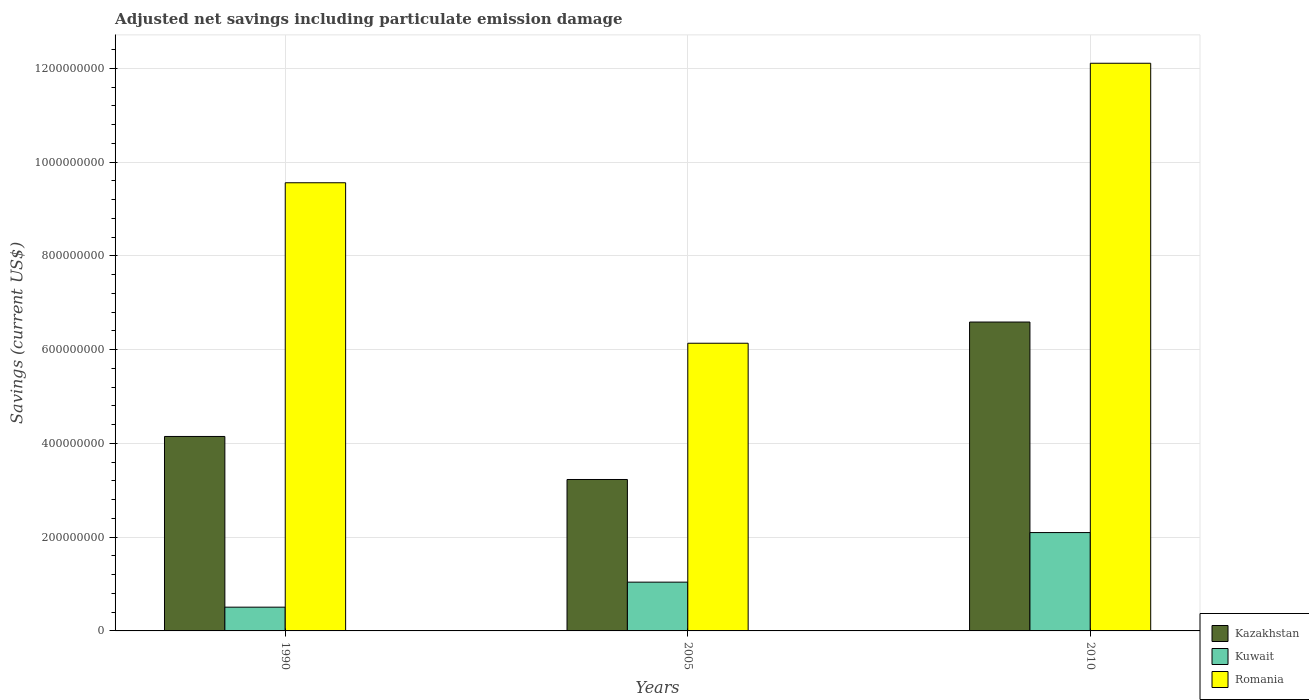How many different coloured bars are there?
Keep it short and to the point. 3. Are the number of bars per tick equal to the number of legend labels?
Your answer should be compact. Yes. How many bars are there on the 2nd tick from the left?
Offer a very short reply. 3. In how many cases, is the number of bars for a given year not equal to the number of legend labels?
Ensure brevity in your answer.  0. What is the net savings in Kazakhstan in 2005?
Give a very brief answer. 3.23e+08. Across all years, what is the maximum net savings in Romania?
Offer a terse response. 1.21e+09. Across all years, what is the minimum net savings in Kazakhstan?
Offer a very short reply. 3.23e+08. In which year was the net savings in Romania maximum?
Make the answer very short. 2010. In which year was the net savings in Romania minimum?
Provide a short and direct response. 2005. What is the total net savings in Kuwait in the graph?
Your answer should be very brief. 3.65e+08. What is the difference between the net savings in Kuwait in 1990 and that in 2010?
Offer a very short reply. -1.59e+08. What is the difference between the net savings in Kuwait in 2005 and the net savings in Romania in 1990?
Ensure brevity in your answer.  -8.52e+08. What is the average net savings in Kuwait per year?
Ensure brevity in your answer.  1.22e+08. In the year 1990, what is the difference between the net savings in Kazakhstan and net savings in Kuwait?
Offer a terse response. 3.64e+08. In how many years, is the net savings in Romania greater than 120000000 US$?
Your response must be concise. 3. What is the ratio of the net savings in Romania in 1990 to that in 2005?
Provide a succinct answer. 1.56. Is the net savings in Romania in 1990 less than that in 2010?
Your answer should be very brief. Yes. What is the difference between the highest and the second highest net savings in Kazakhstan?
Offer a terse response. 2.44e+08. What is the difference between the highest and the lowest net savings in Romania?
Provide a short and direct response. 5.97e+08. In how many years, is the net savings in Romania greater than the average net savings in Romania taken over all years?
Your answer should be very brief. 2. Is the sum of the net savings in Kazakhstan in 2005 and 2010 greater than the maximum net savings in Kuwait across all years?
Give a very brief answer. Yes. What does the 1st bar from the left in 2010 represents?
Provide a succinct answer. Kazakhstan. What does the 2nd bar from the right in 1990 represents?
Provide a short and direct response. Kuwait. Is it the case that in every year, the sum of the net savings in Romania and net savings in Kazakhstan is greater than the net savings in Kuwait?
Offer a very short reply. Yes. How many bars are there?
Give a very brief answer. 9. Does the graph contain any zero values?
Your answer should be compact. No. Does the graph contain grids?
Your answer should be very brief. Yes. Where does the legend appear in the graph?
Provide a succinct answer. Bottom right. How are the legend labels stacked?
Your answer should be very brief. Vertical. What is the title of the graph?
Provide a short and direct response. Adjusted net savings including particulate emission damage. Does "Dominica" appear as one of the legend labels in the graph?
Provide a short and direct response. No. What is the label or title of the X-axis?
Provide a short and direct response. Years. What is the label or title of the Y-axis?
Provide a succinct answer. Savings (current US$). What is the Savings (current US$) of Kazakhstan in 1990?
Make the answer very short. 4.15e+08. What is the Savings (current US$) of Kuwait in 1990?
Your answer should be very brief. 5.07e+07. What is the Savings (current US$) of Romania in 1990?
Offer a very short reply. 9.56e+08. What is the Savings (current US$) of Kazakhstan in 2005?
Ensure brevity in your answer.  3.23e+08. What is the Savings (current US$) in Kuwait in 2005?
Offer a very short reply. 1.04e+08. What is the Savings (current US$) in Romania in 2005?
Ensure brevity in your answer.  6.14e+08. What is the Savings (current US$) in Kazakhstan in 2010?
Your answer should be compact. 6.59e+08. What is the Savings (current US$) in Kuwait in 2010?
Offer a terse response. 2.10e+08. What is the Savings (current US$) in Romania in 2010?
Provide a succinct answer. 1.21e+09. Across all years, what is the maximum Savings (current US$) of Kazakhstan?
Your answer should be very brief. 6.59e+08. Across all years, what is the maximum Savings (current US$) of Kuwait?
Provide a succinct answer. 2.10e+08. Across all years, what is the maximum Savings (current US$) of Romania?
Keep it short and to the point. 1.21e+09. Across all years, what is the minimum Savings (current US$) in Kazakhstan?
Give a very brief answer. 3.23e+08. Across all years, what is the minimum Savings (current US$) of Kuwait?
Give a very brief answer. 5.07e+07. Across all years, what is the minimum Savings (current US$) of Romania?
Keep it short and to the point. 6.14e+08. What is the total Savings (current US$) of Kazakhstan in the graph?
Provide a succinct answer. 1.40e+09. What is the total Savings (current US$) in Kuwait in the graph?
Ensure brevity in your answer.  3.65e+08. What is the total Savings (current US$) in Romania in the graph?
Make the answer very short. 2.78e+09. What is the difference between the Savings (current US$) in Kazakhstan in 1990 and that in 2005?
Provide a succinct answer. 9.18e+07. What is the difference between the Savings (current US$) in Kuwait in 1990 and that in 2005?
Your answer should be very brief. -5.34e+07. What is the difference between the Savings (current US$) of Romania in 1990 and that in 2005?
Ensure brevity in your answer.  3.42e+08. What is the difference between the Savings (current US$) in Kazakhstan in 1990 and that in 2010?
Your answer should be compact. -2.44e+08. What is the difference between the Savings (current US$) of Kuwait in 1990 and that in 2010?
Provide a short and direct response. -1.59e+08. What is the difference between the Savings (current US$) of Romania in 1990 and that in 2010?
Ensure brevity in your answer.  -2.55e+08. What is the difference between the Savings (current US$) of Kazakhstan in 2005 and that in 2010?
Keep it short and to the point. -3.36e+08. What is the difference between the Savings (current US$) in Kuwait in 2005 and that in 2010?
Ensure brevity in your answer.  -1.06e+08. What is the difference between the Savings (current US$) of Romania in 2005 and that in 2010?
Offer a terse response. -5.97e+08. What is the difference between the Savings (current US$) of Kazakhstan in 1990 and the Savings (current US$) of Kuwait in 2005?
Give a very brief answer. 3.11e+08. What is the difference between the Savings (current US$) in Kazakhstan in 1990 and the Savings (current US$) in Romania in 2005?
Your answer should be very brief. -1.99e+08. What is the difference between the Savings (current US$) of Kuwait in 1990 and the Savings (current US$) of Romania in 2005?
Your response must be concise. -5.63e+08. What is the difference between the Savings (current US$) of Kazakhstan in 1990 and the Savings (current US$) of Kuwait in 2010?
Your answer should be very brief. 2.05e+08. What is the difference between the Savings (current US$) of Kazakhstan in 1990 and the Savings (current US$) of Romania in 2010?
Ensure brevity in your answer.  -7.96e+08. What is the difference between the Savings (current US$) in Kuwait in 1990 and the Savings (current US$) in Romania in 2010?
Provide a succinct answer. -1.16e+09. What is the difference between the Savings (current US$) of Kazakhstan in 2005 and the Savings (current US$) of Kuwait in 2010?
Provide a succinct answer. 1.13e+08. What is the difference between the Savings (current US$) of Kazakhstan in 2005 and the Savings (current US$) of Romania in 2010?
Your answer should be very brief. -8.88e+08. What is the difference between the Savings (current US$) of Kuwait in 2005 and the Savings (current US$) of Romania in 2010?
Ensure brevity in your answer.  -1.11e+09. What is the average Savings (current US$) in Kazakhstan per year?
Make the answer very short. 4.66e+08. What is the average Savings (current US$) of Kuwait per year?
Ensure brevity in your answer.  1.22e+08. What is the average Savings (current US$) in Romania per year?
Provide a succinct answer. 9.27e+08. In the year 1990, what is the difference between the Savings (current US$) in Kazakhstan and Savings (current US$) in Kuwait?
Your answer should be compact. 3.64e+08. In the year 1990, what is the difference between the Savings (current US$) in Kazakhstan and Savings (current US$) in Romania?
Offer a very short reply. -5.41e+08. In the year 1990, what is the difference between the Savings (current US$) of Kuwait and Savings (current US$) of Romania?
Give a very brief answer. -9.05e+08. In the year 2005, what is the difference between the Savings (current US$) in Kazakhstan and Savings (current US$) in Kuwait?
Offer a very short reply. 2.19e+08. In the year 2005, what is the difference between the Savings (current US$) in Kazakhstan and Savings (current US$) in Romania?
Offer a very short reply. -2.91e+08. In the year 2005, what is the difference between the Savings (current US$) in Kuwait and Savings (current US$) in Romania?
Offer a very short reply. -5.10e+08. In the year 2010, what is the difference between the Savings (current US$) of Kazakhstan and Savings (current US$) of Kuwait?
Provide a short and direct response. 4.49e+08. In the year 2010, what is the difference between the Savings (current US$) of Kazakhstan and Savings (current US$) of Romania?
Your response must be concise. -5.52e+08. In the year 2010, what is the difference between the Savings (current US$) in Kuwait and Savings (current US$) in Romania?
Offer a terse response. -1.00e+09. What is the ratio of the Savings (current US$) of Kazakhstan in 1990 to that in 2005?
Your answer should be compact. 1.28. What is the ratio of the Savings (current US$) of Kuwait in 1990 to that in 2005?
Keep it short and to the point. 0.49. What is the ratio of the Savings (current US$) of Romania in 1990 to that in 2005?
Provide a short and direct response. 1.56. What is the ratio of the Savings (current US$) of Kazakhstan in 1990 to that in 2010?
Provide a short and direct response. 0.63. What is the ratio of the Savings (current US$) of Kuwait in 1990 to that in 2010?
Offer a terse response. 0.24. What is the ratio of the Savings (current US$) of Romania in 1990 to that in 2010?
Make the answer very short. 0.79. What is the ratio of the Savings (current US$) in Kazakhstan in 2005 to that in 2010?
Your answer should be compact. 0.49. What is the ratio of the Savings (current US$) of Kuwait in 2005 to that in 2010?
Make the answer very short. 0.5. What is the ratio of the Savings (current US$) of Romania in 2005 to that in 2010?
Ensure brevity in your answer.  0.51. What is the difference between the highest and the second highest Savings (current US$) in Kazakhstan?
Provide a succinct answer. 2.44e+08. What is the difference between the highest and the second highest Savings (current US$) of Kuwait?
Make the answer very short. 1.06e+08. What is the difference between the highest and the second highest Savings (current US$) of Romania?
Offer a terse response. 2.55e+08. What is the difference between the highest and the lowest Savings (current US$) of Kazakhstan?
Your response must be concise. 3.36e+08. What is the difference between the highest and the lowest Savings (current US$) in Kuwait?
Make the answer very short. 1.59e+08. What is the difference between the highest and the lowest Savings (current US$) of Romania?
Your answer should be very brief. 5.97e+08. 